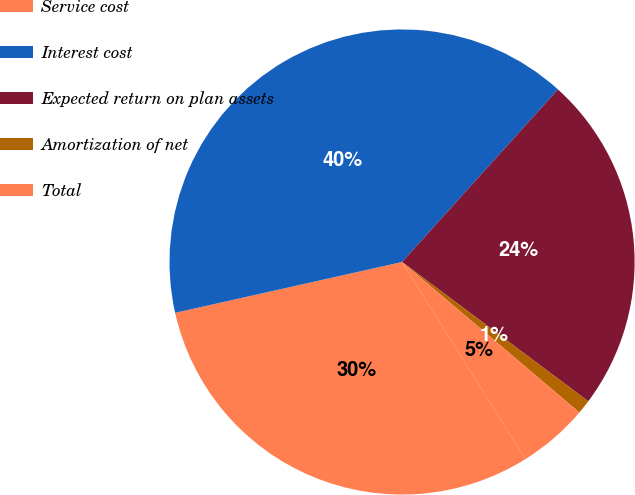Convert chart. <chart><loc_0><loc_0><loc_500><loc_500><pie_chart><fcel>Service cost<fcel>Interest cost<fcel>Expected return on plan assets<fcel>Amortization of net<fcel>Total<nl><fcel>30.39%<fcel>40.2%<fcel>23.53%<fcel>0.98%<fcel>4.9%<nl></chart> 